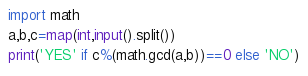<code> <loc_0><loc_0><loc_500><loc_500><_Python_>import math
a,b,c=map(int,input().split())
print('YES' if c%(math.gcd(a,b))==0 else 'NO')</code> 